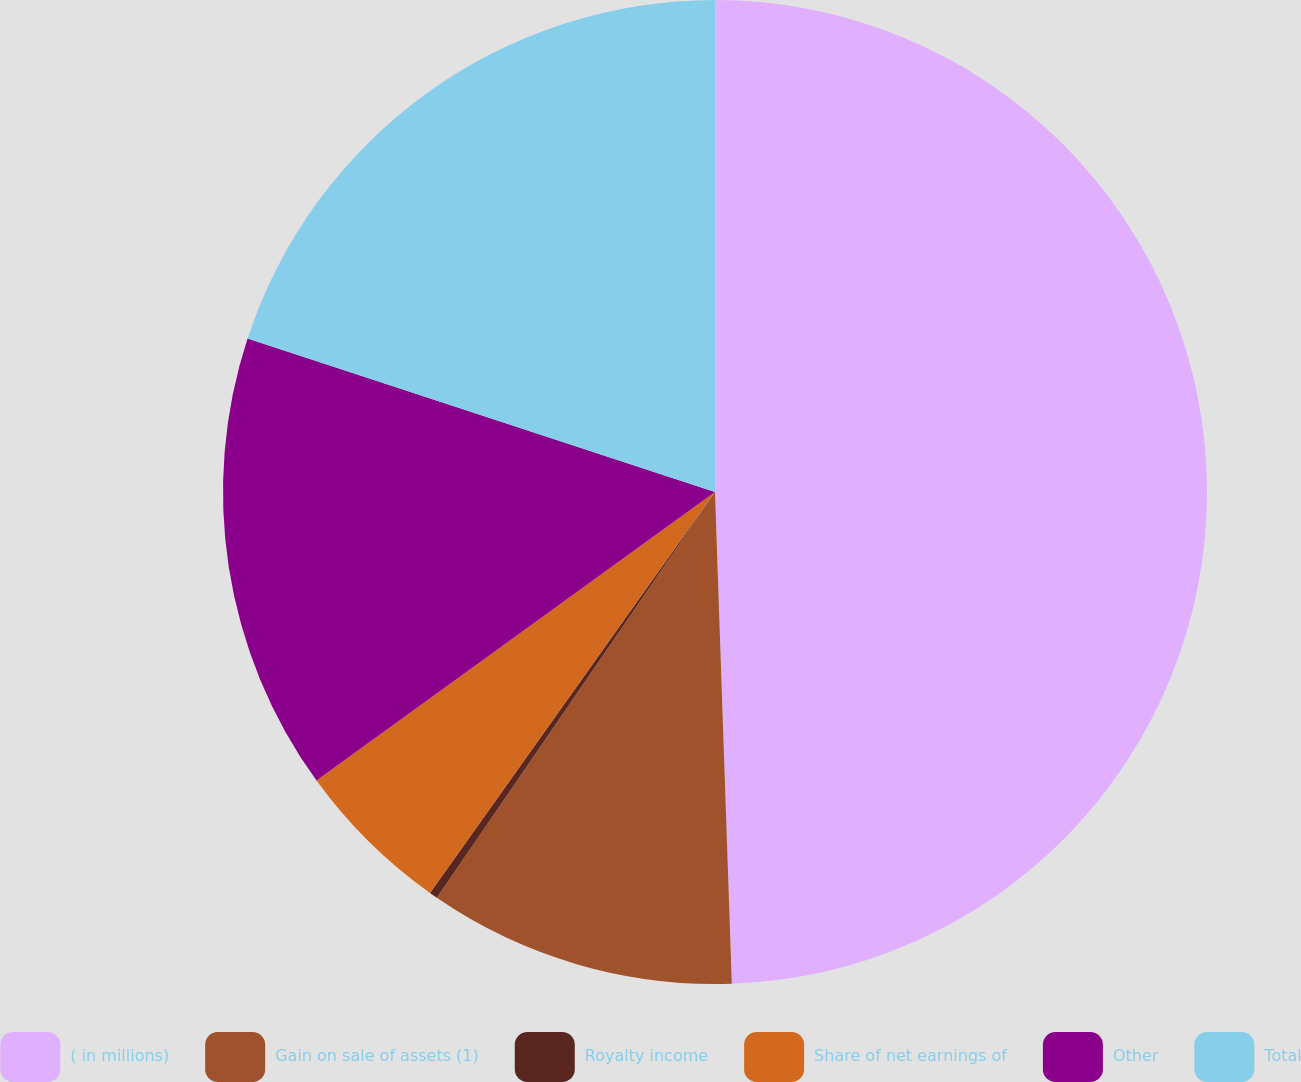Convert chart. <chart><loc_0><loc_0><loc_500><loc_500><pie_chart><fcel>( in millions)<fcel>Gain on sale of assets (1)<fcel>Royalty income<fcel>Share of net earnings of<fcel>Other<fcel>Total<nl><fcel>49.46%<fcel>10.11%<fcel>0.27%<fcel>5.19%<fcel>15.03%<fcel>19.95%<nl></chart> 